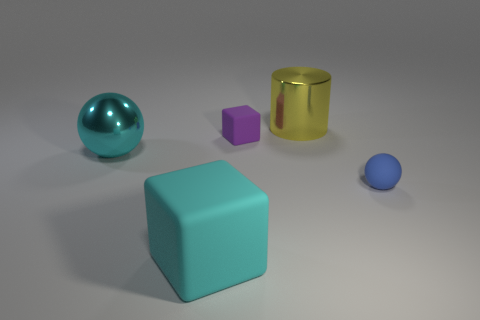Add 4 purple rubber cylinders. How many objects exist? 9 Subtract all cyan blocks. How many blocks are left? 1 Subtract 1 balls. How many balls are left? 1 Subtract all cylinders. How many objects are left? 4 Subtract all brown cubes. Subtract all gray cylinders. How many cubes are left? 2 Subtract all blue spheres. How many blue cylinders are left? 0 Subtract all tiny rubber cubes. Subtract all small purple rubber blocks. How many objects are left? 3 Add 4 rubber cubes. How many rubber cubes are left? 6 Add 4 small green matte things. How many small green matte things exist? 4 Subtract 0 green cylinders. How many objects are left? 5 